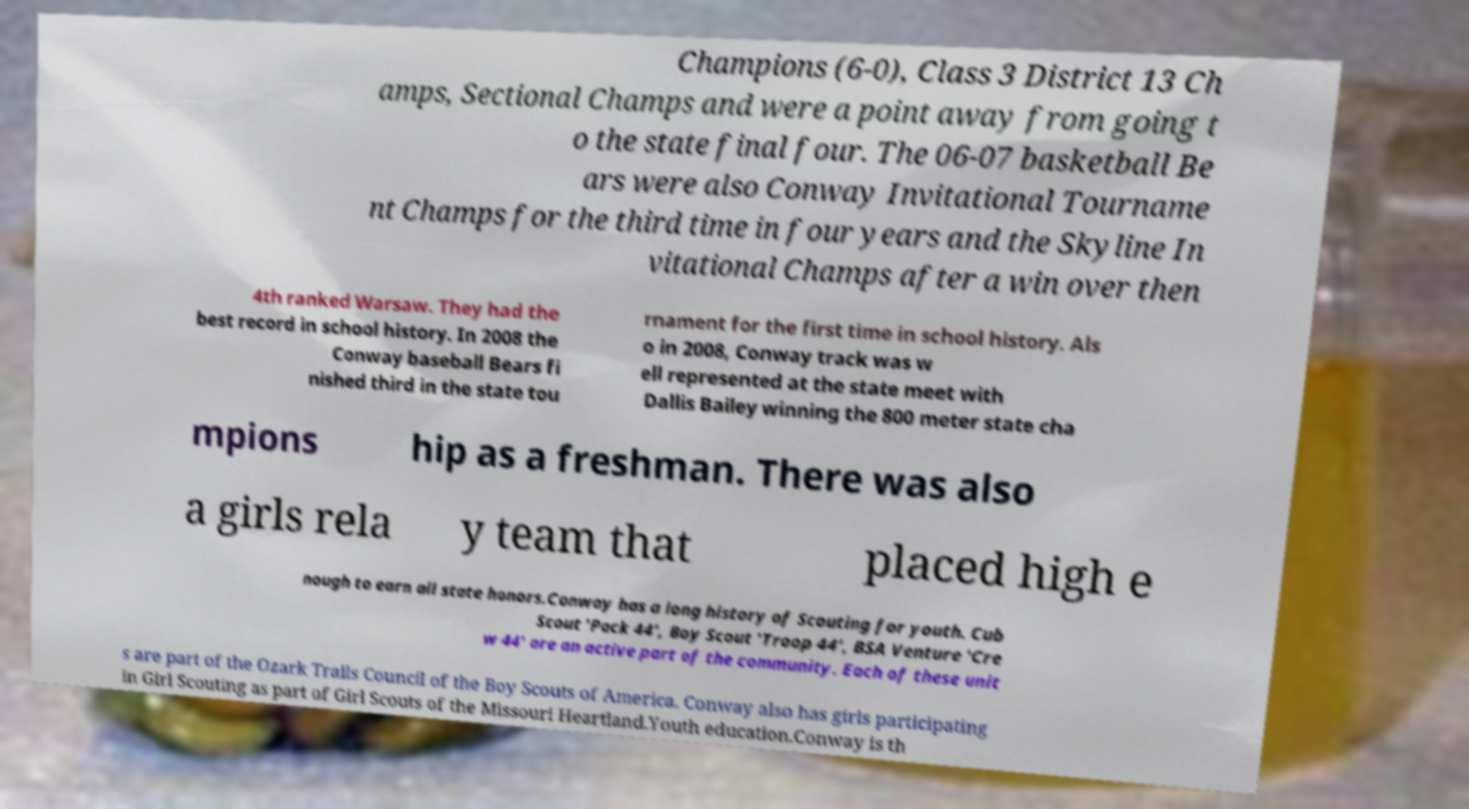What messages or text are displayed in this image? I need them in a readable, typed format. Champions (6-0), Class 3 District 13 Ch amps, Sectional Champs and were a point away from going t o the state final four. The 06-07 basketball Be ars were also Conway Invitational Tourname nt Champs for the third time in four years and the Skyline In vitational Champs after a win over then 4th ranked Warsaw. They had the best record in school history. In 2008 the Conway baseball Bears fi nished third in the state tou rnament for the first time in school history. Als o in 2008, Conway track was w ell represented at the state meet with Dallis Bailey winning the 800 meter state cha mpions hip as a freshman. There was also a girls rela y team that placed high e nough to earn all state honors.Conway has a long history of Scouting for youth. Cub Scout 'Pack 44', Boy Scout 'Troop 44', BSA Venture 'Cre w 44' are an active part of the community. Each of these unit s are part of the Ozark Trails Council of the Boy Scouts of America. Conway also has girls participating in Girl Scouting as part of Girl Scouts of the Missouri Heartland.Youth education.Conway is th 